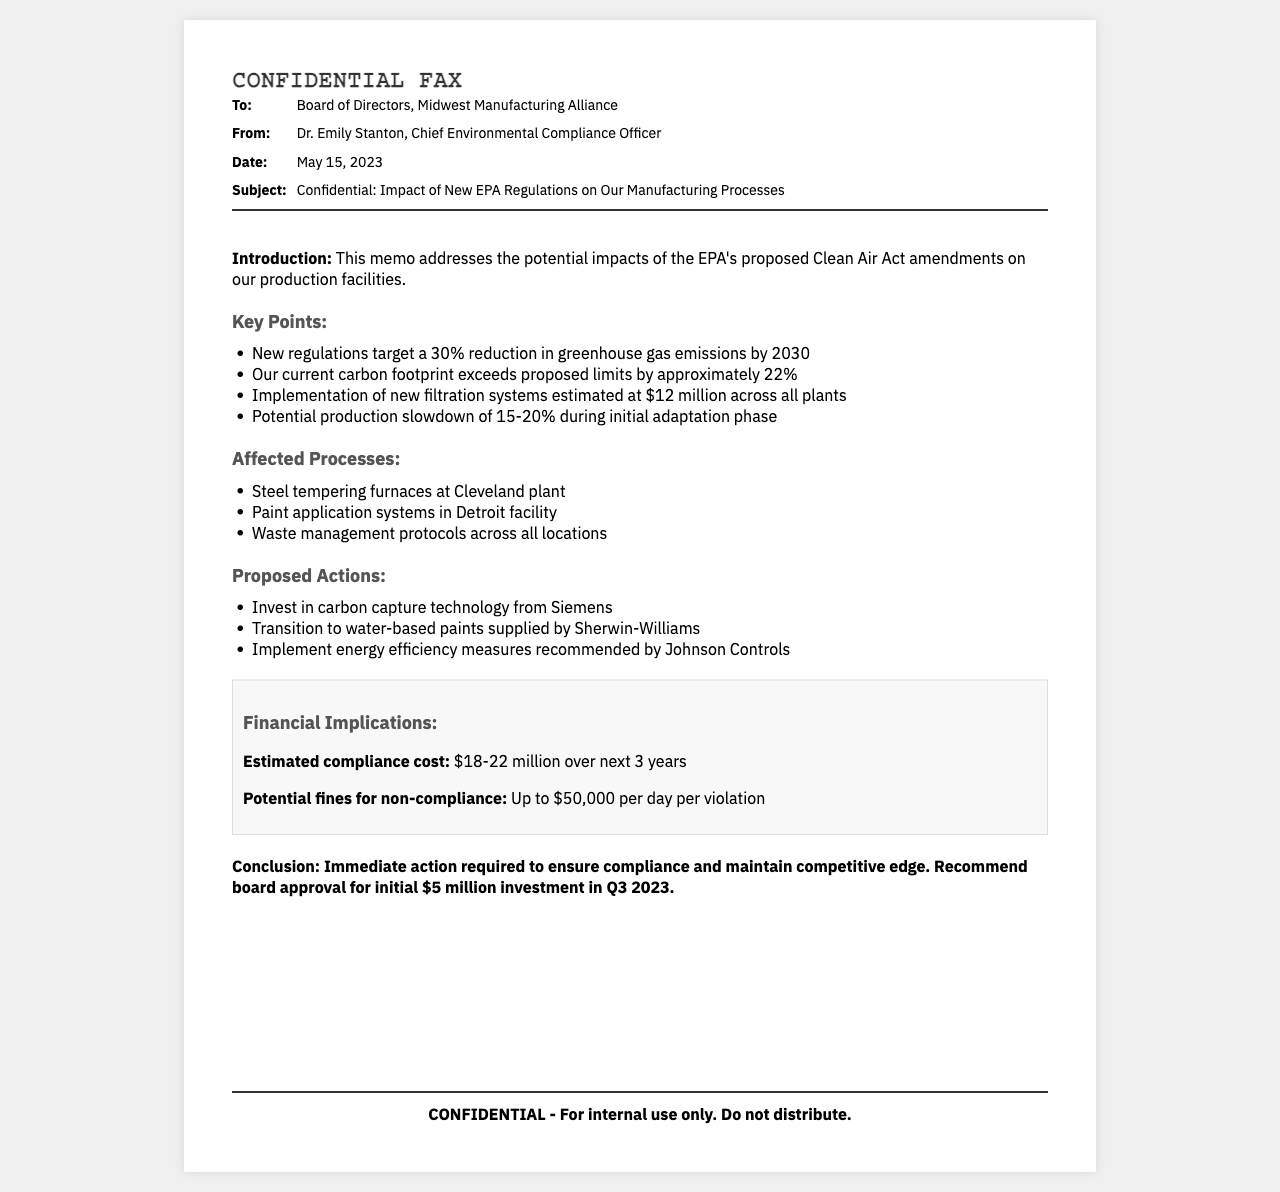What is the document type? The document is labeled as a "Confidential Fax," indicating its nature and purpose.
Answer: Confidential Fax Who is the author of the memo? The memo is authored by Dr. Emily Stanton, who holds the position of Chief Environmental Compliance Officer.
Answer: Dr. Emily Stanton What is the estimated compliance cost range? The document provides a range for the estimated compliance cost over the next three years, which is $18-22 million.
Answer: $18-22 million What percentage reduction in greenhouse gas emissions is targeted by the new regulations? The regulations proposed aim for a 30% reduction in greenhouse gas emissions by 2030.
Answer: 30% What is the potential production slowdown during adaptation? The memo indicates a potential production slowdown of 15-20% during the initial adaptation phase.
Answer: 15-20% What is the conclusion regarding immediate actions? The document concludes with a recommendation for immediate action to ensure compliance and maintain a competitive edge.
Answer: Immediate action required Which manufacturing processes are affected? The memo lists the steel tempering furnaces, paint application systems, and waste management protocols as affected processes.
Answer: Steel tempering furnaces, paint application systems, waste management protocols What should the board approve for initial investment? The memo recommends board approval for an initial investment of $5 million in Q3 2023.
Answer: $5 million 